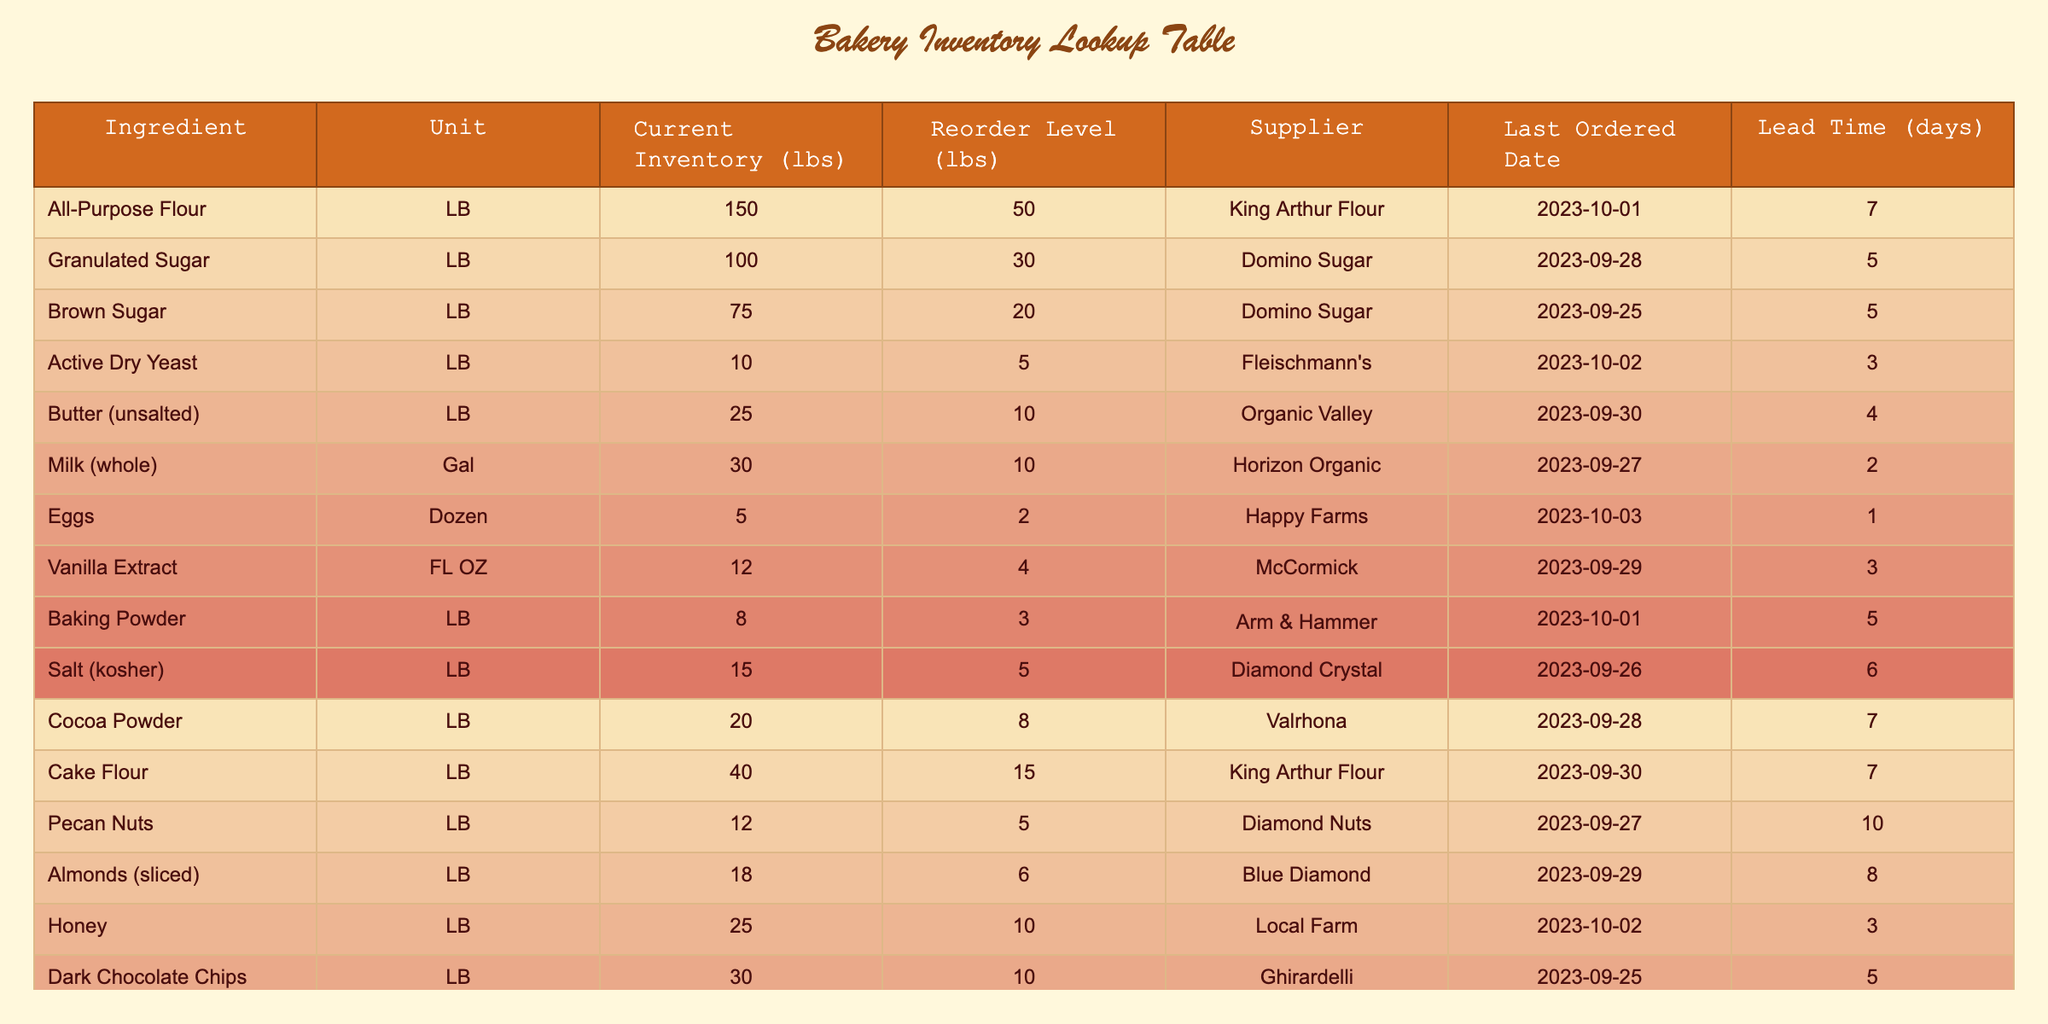What is the current inventory level of Active Dry Yeast? The table shows that the current inventory of Active Dry Yeast is listed under the "Current Inventory (lbs)" column. For Active Dry Yeast, the value is 10 lbs.
Answer: 10 lbs Which ingredient has the lowest current inventory? To determine the lowest current inventory, we can compare the values in the "Current Inventory (lbs)" column. The lowest value is for Active Dry Yeast with 10 lbs, which is the smallest compared to all other ingredients.
Answer: Active Dry Yeast How many pounds of Granulated Sugar do we have above the reorder level? The current inventory of Granulated Sugar is 100 lbs, and the reorder level is 30 lbs. We subtract the reorder level from the current inventory: 100 - 30 = 70 lbs. Therefore, there are 70 lbs above the reorder level.
Answer: 70 lbs True or False: There are more Chocolate Chips in inventory than Baking Powder. The current inventory for Dark Chocolate Chips is 30 lbs, and for Baking Powder, it is 8 lbs. Since 30 > 8, the statement is true.
Answer: True If we sum the current inventory of Flour (both All-Purpose and Cake Flour), how many pounds do we have in total? The current inventory of All-Purpose Flour is 150 lbs and Cake Flour is 40 lbs. To find the total, we add these two amounts: 150 + 40 = 190 lbs.
Answer: 190 lbs What is the lead time for Butter (unsalted)? The lead time for any ingredient is found in the corresponding row. For Butter (unsalted), the lead time is 4 days, as indicated in the table.
Answer: 4 days Which supplier provides the Vanilla Extract? The table lists Vanilla Extract with its corresponding supplier in the same row. According to the information, the supplier for Vanilla Extract is McCormick.
Answer: McCormick What is the difference between the current inventory level of Eggs and the reorder level? The current inventory level of Eggs is 5 dozen while the reorder level is 2 dozen. The difference can be calculated by subtracting the reorder level from the current inventory: 5 - 2 = 3 dozen.
Answer: 3 dozen How many pounds of Pecan Nuts do we have, and how many do we need to reorder? The current inventory for Pecan Nuts is 12 lbs, and the reorder level is 5 lbs. We recognize these values from the table directly.
Answer: Current: 12 lbs, Reorder Level: 5 lbs 